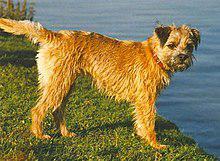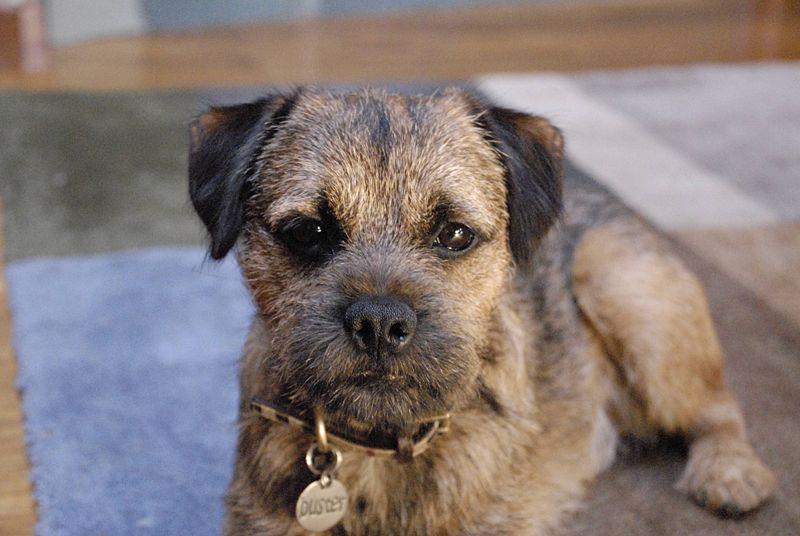The first image is the image on the left, the second image is the image on the right. Analyze the images presented: Is the assertion "Right image shows a dog standing in profile on grass." valid? Answer yes or no. No. The first image is the image on the left, the second image is the image on the right. Assess this claim about the two images: "The animal in one of the images is on all fours and facing right". Correct or not? Answer yes or no. Yes. 